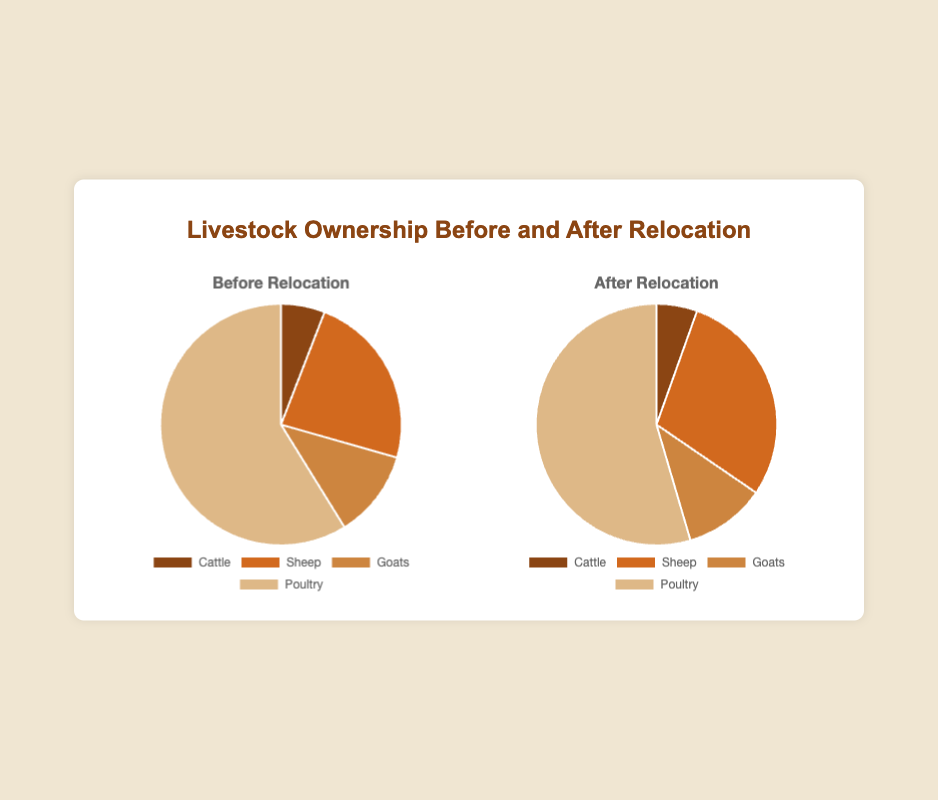What is the total number of livestock before relocation? To find the total number of livestock before relocation, sum up the values for each type of livestock before relocation: Cattle (50) + Sheep (200) + Goats (100) + Poultry (500) = 850
Answer: 850 Which type of livestock showed the highest decrease in ownership after relocation? The decrease in ownership can be calculated by subtracting the 'After Relocation' value from the 'Before Relocation' value for each type: Cattle (50 - 15) = 35, Sheep (200 - 80) = 120, Goats (100 - 30) = 70, Poultry (500 - 150) = 350. The largest decrease is seen in Poultry with a decrease of 350.
Answer: Poultry What proportion of the total livestock does Poultry represent after relocation? First, calculate the total livestock after relocation by summing up the values: Cattle (15) + Sheep (80) + Goats (30) + Poultry (150) = 275. Then, find the proportion of Poultry: (150 / 275) * 100 ≈ 54.55%
Answer: 54.55% How much more Poultry was owned compared to Goats before relocation? The difference between Poultry and Goats before relocation is calculated by subtracting the number of Goats (100) from Poultry (500): 500 - 100 = 400
Answer: 400 What is the percentage decrease in Sheep ownership after relocation? To find the percentage decrease, first find the decrease in Sheep ownership (200 - 80 = 120). Then, divide the decrease by the initial amount and multiply by 100: (120 / 200) * 100 = 60%
Answer: 60% Which type of livestock has the smallest number after relocation? Compare the 'After Relocation' values: Cattle (15), Sheep (80), Goats (30), Poultry (150). The smallest number is Cattle with 15.
Answer: Cattle What is the total decrease in livestock ownership after relocation? Calculate the decrease for each type and sum them up: Cattle (50 - 15 = 35), Sheep (200 - 80 = 120), Goats (100 - 30 = 70), Poultry (500 - 150 = 350). Summing these gives: 35 + 120 + 70 + 350 = 575
Answer: 575 What is the overall change in the percentage of Sheep in total livestock ownership before and after relocation? First, calculate the total livestock before relocation (850) and after relocation (275). Then, find the percentage of Sheep ownership in both cases:
Before: (200 / 850) * 100 ≈ 23.53%
After: (80 / 275) * 100 ≈ 29.09%
The overall change is the difference: 29.09% - 23.53% ≈ 5.56%
Answer: 5.56% Which type of livestock remains the most owned after relocation? Compare the 'After Relocation' values: Cattle (15), Sheep (80), Goats (30), Poultry (150). The most owned livestock after relocation is Poultry with 150.
Answer: Poultry 